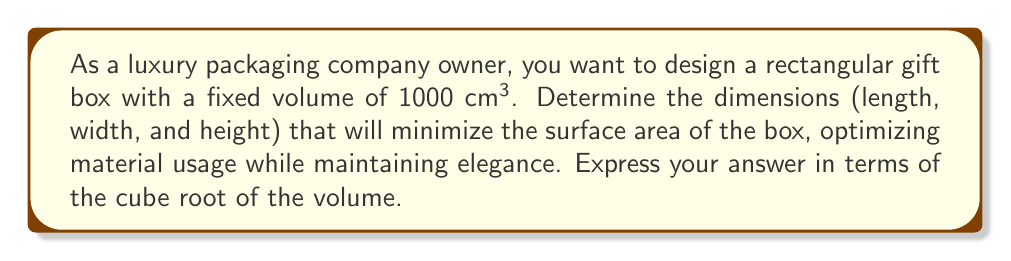Can you solve this math problem? Let's approach this step-by-step using algebraic methods:

1) Let the dimensions of the box be length ($l$), width ($w$), and height ($h$).

2) Given that the volume is fixed at 1000 cm³, we can write:

   $$V = l \cdot w \cdot h = 1000$$

3) The surface area of a rectangular box is given by:

   $$SA = 2(lw + lh + wh)$$

4) Our goal is to minimize the surface area while maintaining the volume constraint. We can use the method of Lagrange multipliers, but there's a simpler approach using the AM-GM inequality.

5) The AM-GM inequality states that the arithmetic mean of a list of non-negative real numbers is greater than or equal to the geometric mean of the same list. Equality holds when all the numbers are the same.

6) In our case, we have:

   $$\frac{lw + lh + wh}{3} \geq \sqrt[3]{lwh} = \sqrt[3]{1000}$$

7) The surface area will be minimized when this inequality becomes an equality, which occurs when:

   $$lw = lh = wh$$

8) This implies that $l = w = h$.

9) Substituting this back into the volume equation:

   $$l^3 = 1000$$
   $$l = \sqrt[3]{1000}$$

10) Therefore, to minimize the surface area, all dimensions should be equal to the cube root of the volume.
Answer: $l = w = h = \sqrt[3]{1000}$ cm 